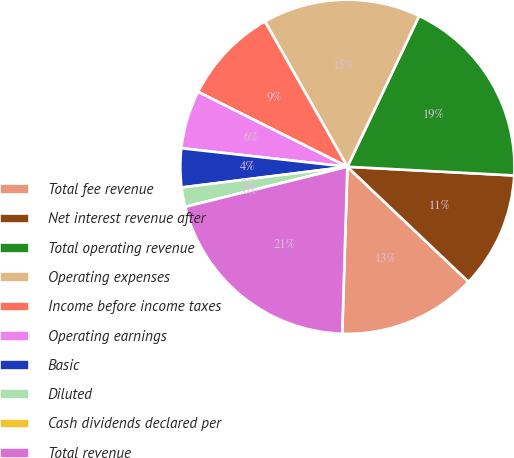<chart> <loc_0><loc_0><loc_500><loc_500><pie_chart><fcel>Total fee revenue<fcel>Net interest revenue after<fcel>Total operating revenue<fcel>Operating expenses<fcel>Income before income taxes<fcel>Operating earnings<fcel>Basic<fcel>Diluted<fcel>Cash dividends declared per<fcel>Total revenue<nl><fcel>13.4%<fcel>11.26%<fcel>18.76%<fcel>15.28%<fcel>9.38%<fcel>5.63%<fcel>3.75%<fcel>1.88%<fcel>0.0%<fcel>20.64%<nl></chart> 